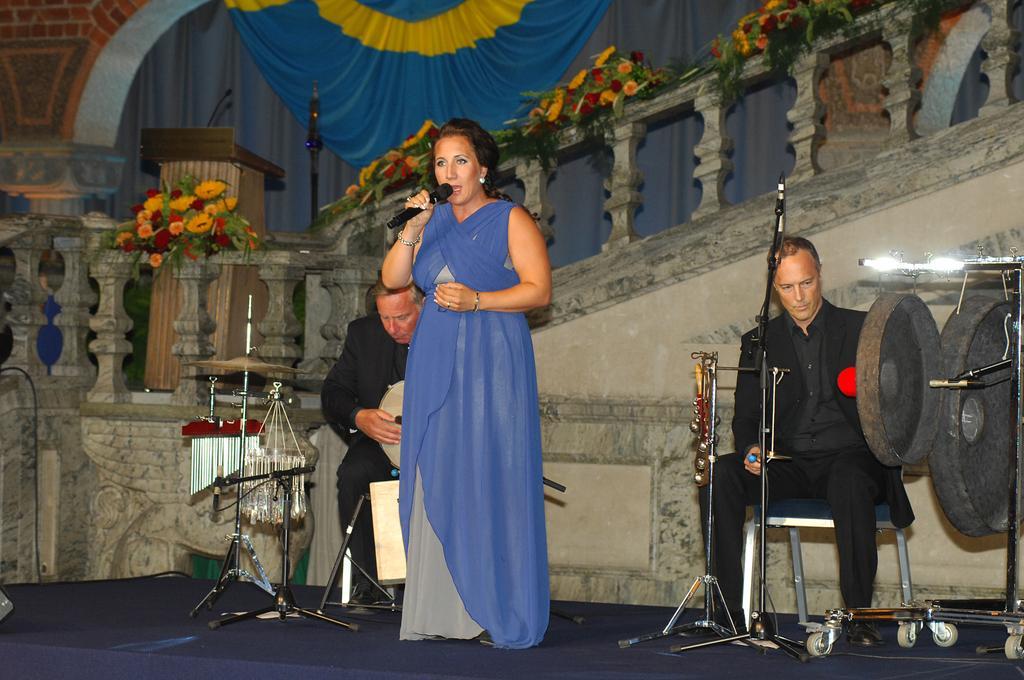How would you summarize this image in a sentence or two? In this image there is a lady standing on the stage and she is holding a mic in her hand. On the both the sides of the lady there are two persons sitting on the chairs and playing musical instruments, behind them there are stairs and on the top of the stairs there are flowers. In the background there is a curtain hanging on the wall. 